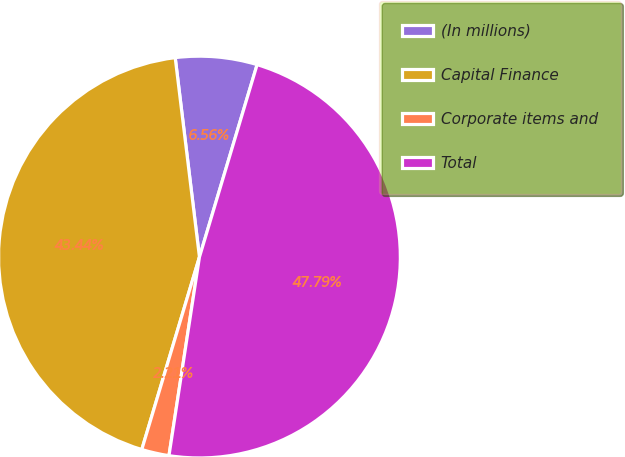Convert chart to OTSL. <chart><loc_0><loc_0><loc_500><loc_500><pie_chart><fcel>(In millions)<fcel>Capital Finance<fcel>Corporate items and<fcel>Total<nl><fcel>6.56%<fcel>43.44%<fcel>2.21%<fcel>47.79%<nl></chart> 